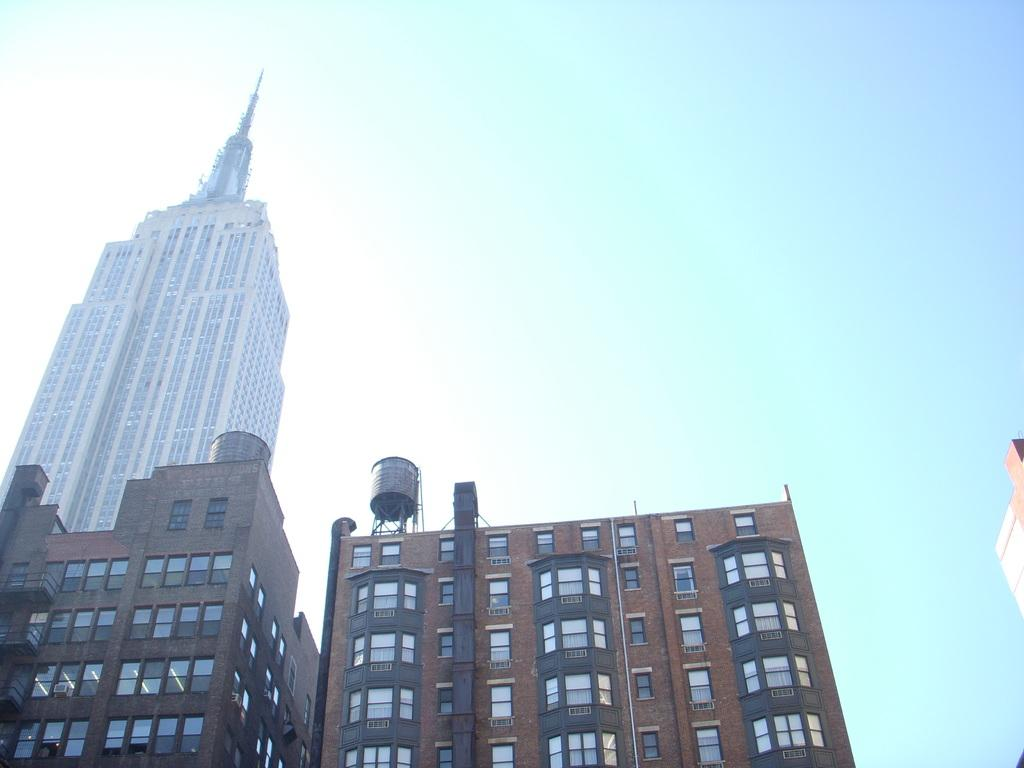What type of buildings are visible in the image? The buildings in the image have glass windows. What can be seen in the background of the image? The background of the image includes a blue sky. How many icicles are hanging from the buildings in the image? There are no icicles present in the image; the buildings have glass windows. What fictional characters can be seen interacting with the buildings in the image? There are no fictional characters present in the image. 